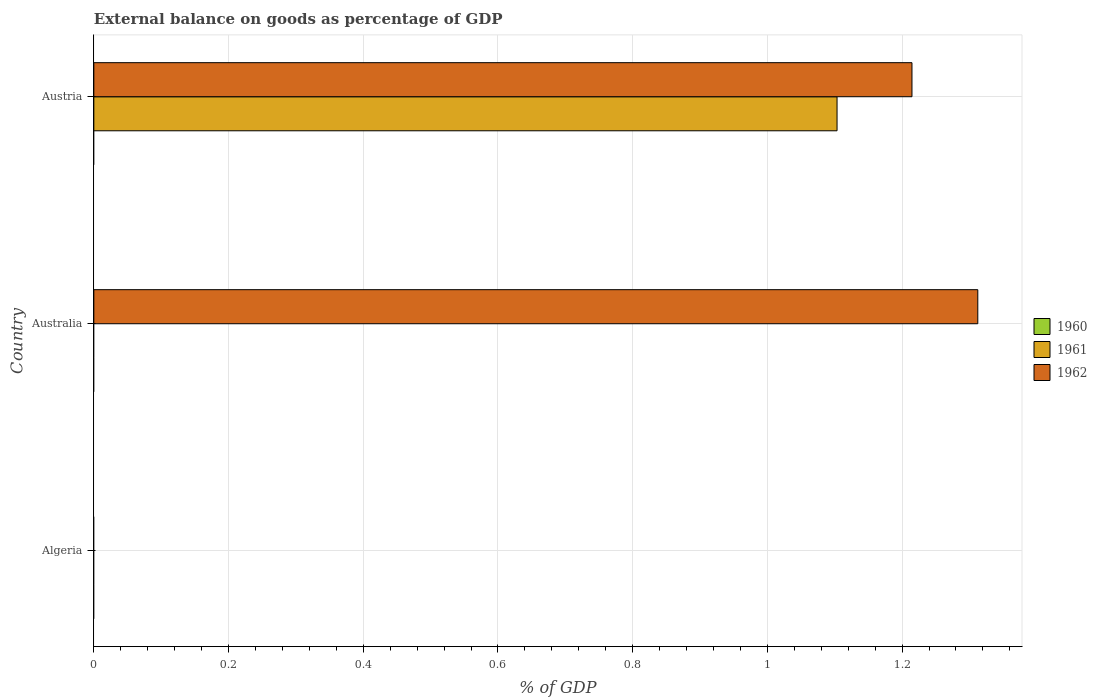Are the number of bars per tick equal to the number of legend labels?
Keep it short and to the point. No. How many bars are there on the 1st tick from the bottom?
Ensure brevity in your answer.  0. What is the label of the 3rd group of bars from the top?
Make the answer very short. Algeria. Across all countries, what is the maximum external balance on goods as percentage of GDP in 1961?
Keep it short and to the point. 1.1. In which country was the external balance on goods as percentage of GDP in 1962 maximum?
Give a very brief answer. Australia. What is the total external balance on goods as percentage of GDP in 1960 in the graph?
Offer a very short reply. 0. What is the difference between the external balance on goods as percentage of GDP in 1962 in Australia and that in Austria?
Make the answer very short. 0.1. What is the difference between the external balance on goods as percentage of GDP in 1961 in Austria and the external balance on goods as percentage of GDP in 1962 in Australia?
Ensure brevity in your answer.  -0.21. What is the average external balance on goods as percentage of GDP in 1962 per country?
Keep it short and to the point. 0.84. What is the ratio of the external balance on goods as percentage of GDP in 1962 in Australia to that in Austria?
Give a very brief answer. 1.08. Is the external balance on goods as percentage of GDP in 1962 in Australia less than that in Austria?
Keep it short and to the point. No. What is the difference between the highest and the lowest external balance on goods as percentage of GDP in 1961?
Give a very brief answer. 1.1. Is the sum of the external balance on goods as percentage of GDP in 1962 in Australia and Austria greater than the maximum external balance on goods as percentage of GDP in 1960 across all countries?
Ensure brevity in your answer.  Yes. Are all the bars in the graph horizontal?
Provide a succinct answer. Yes. How many countries are there in the graph?
Provide a short and direct response. 3. What is the difference between two consecutive major ticks on the X-axis?
Provide a short and direct response. 0.2. Are the values on the major ticks of X-axis written in scientific E-notation?
Make the answer very short. No. Does the graph contain any zero values?
Ensure brevity in your answer.  Yes. Does the graph contain grids?
Ensure brevity in your answer.  Yes. Where does the legend appear in the graph?
Keep it short and to the point. Center right. How are the legend labels stacked?
Offer a very short reply. Vertical. What is the title of the graph?
Your response must be concise. External balance on goods as percentage of GDP. What is the label or title of the X-axis?
Your answer should be compact. % of GDP. What is the % of GDP in 1962 in Australia?
Provide a succinct answer. 1.31. What is the % of GDP in 1961 in Austria?
Offer a very short reply. 1.1. What is the % of GDP in 1962 in Austria?
Offer a terse response. 1.21. Across all countries, what is the maximum % of GDP of 1961?
Ensure brevity in your answer.  1.1. Across all countries, what is the maximum % of GDP of 1962?
Your answer should be compact. 1.31. Across all countries, what is the minimum % of GDP in 1962?
Your response must be concise. 0. What is the total % of GDP in 1960 in the graph?
Provide a short and direct response. 0. What is the total % of GDP of 1961 in the graph?
Provide a succinct answer. 1.1. What is the total % of GDP of 1962 in the graph?
Keep it short and to the point. 2.53. What is the difference between the % of GDP in 1962 in Australia and that in Austria?
Offer a terse response. 0.1. What is the average % of GDP in 1961 per country?
Your response must be concise. 0.37. What is the average % of GDP of 1962 per country?
Offer a very short reply. 0.84. What is the difference between the % of GDP in 1961 and % of GDP in 1962 in Austria?
Make the answer very short. -0.11. What is the ratio of the % of GDP of 1962 in Australia to that in Austria?
Make the answer very short. 1.08. What is the difference between the highest and the lowest % of GDP of 1961?
Make the answer very short. 1.1. What is the difference between the highest and the lowest % of GDP of 1962?
Your answer should be very brief. 1.31. 